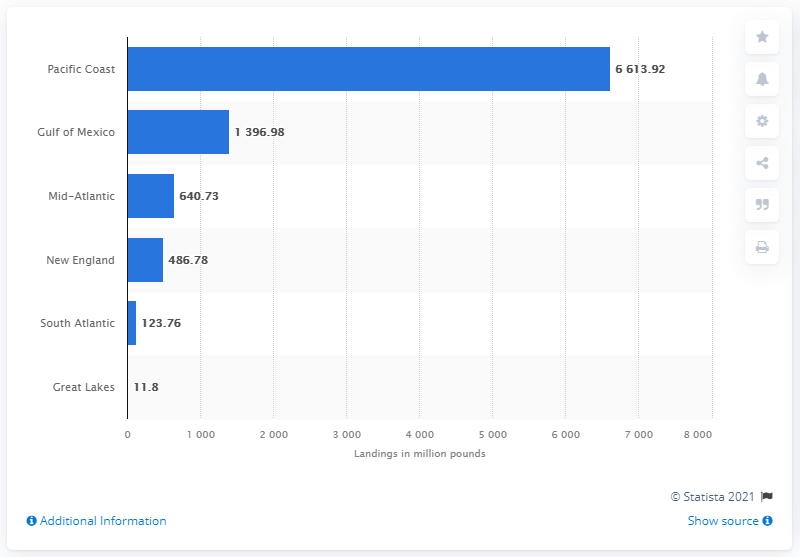Outline some significant characteristics in this image. In 2019, the amount of seafood industry landings on the Pacific Coast was 6,613.92 metric tons. 